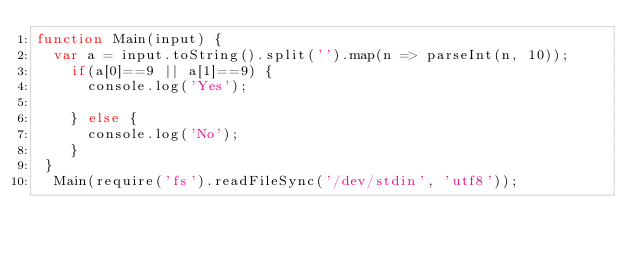<code> <loc_0><loc_0><loc_500><loc_500><_JavaScript_>function Main(input) {
  var a = input.toString().split('').map(n => parseInt(n, 10));
    if(a[0]==9 || a[1]==9) {
      console.log('Yes');

    } else {
      console.log('No');
    }
 }
  Main(require('fs').readFileSync('/dev/stdin', 'utf8'));</code> 